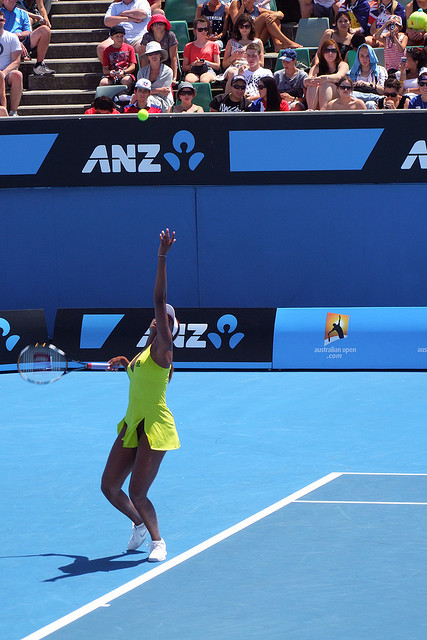Please transcribe the text in this image. ANZ A Z 